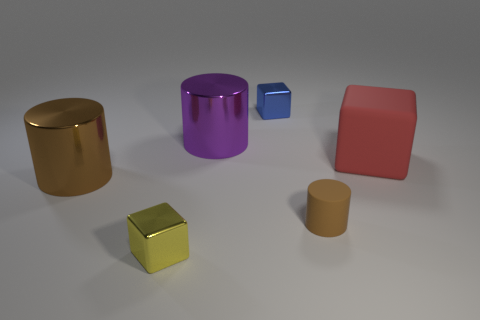What number of objects are blocks in front of the red block or yellow objects?
Ensure brevity in your answer.  1. There is a yellow thing; are there any big brown cylinders on the left side of it?
Your answer should be very brief. Yes. There is a thing that is the same color as the matte cylinder; what is it made of?
Your answer should be compact. Metal. Are the brown cylinder that is to the right of the blue block and the large brown thing made of the same material?
Offer a terse response. No. There is a tiny shiny thing behind the large cylinder to the left of the tiny yellow object; are there any shiny cylinders on the left side of it?
Your answer should be very brief. Yes. How many cylinders are either tiny matte objects or big purple shiny objects?
Your response must be concise. 2. There is a cylinder that is in front of the big brown cylinder; what is it made of?
Make the answer very short. Rubber. What size is the shiny thing that is the same color as the small cylinder?
Your response must be concise. Large. There is a rubber object that is in front of the brown shiny object; does it have the same color as the big metallic thing on the left side of the yellow object?
Your answer should be very brief. Yes. How many objects are yellow cylinders or small metallic objects?
Your answer should be very brief. 2. 